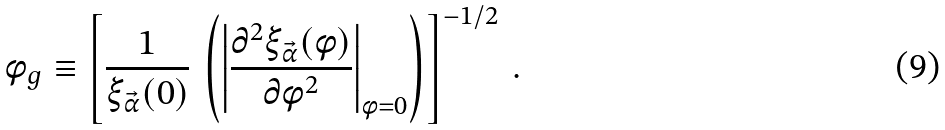<formula> <loc_0><loc_0><loc_500><loc_500>\phi _ { g } \equiv \left [ \frac { 1 } { \xi _ { \vec { \alpha } } ( 0 ) } \, \left ( \left | \frac { \partial ^ { 2 } \xi _ { \vec { \alpha } } ( \phi ) } { \partial \phi ^ { 2 } } \right | _ { \phi = 0 } \right ) \right ] ^ { - 1 / 2 } \, .</formula> 